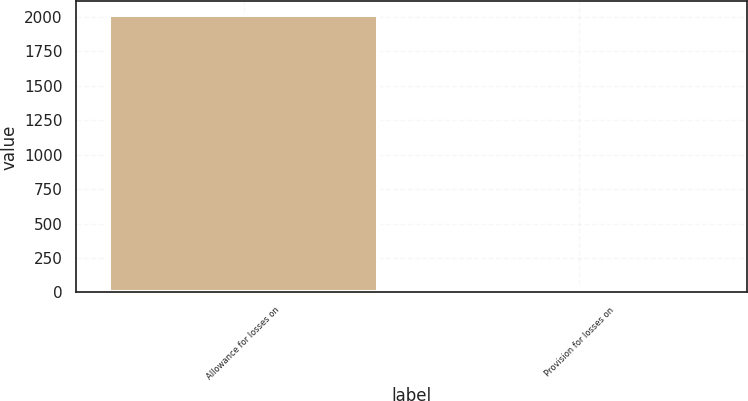<chart> <loc_0><loc_0><loc_500><loc_500><bar_chart><fcel>Allowance for losses on<fcel>Provision for losses on<nl><fcel>2013<fcel>29<nl></chart> 